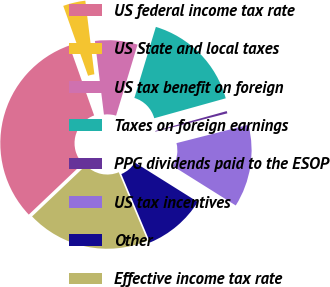Convert chart to OTSL. <chart><loc_0><loc_0><loc_500><loc_500><pie_chart><fcel>US federal income tax rate<fcel>US State and local taxes<fcel>US tax benefit on foreign<fcel>Taxes on foreign earnings<fcel>PPG dividends paid to the ESOP<fcel>US tax incentives<fcel>Other<fcel>Effective income tax rate<nl><fcel>31.65%<fcel>3.49%<fcel>6.62%<fcel>16.0%<fcel>0.36%<fcel>12.88%<fcel>9.75%<fcel>19.26%<nl></chart> 